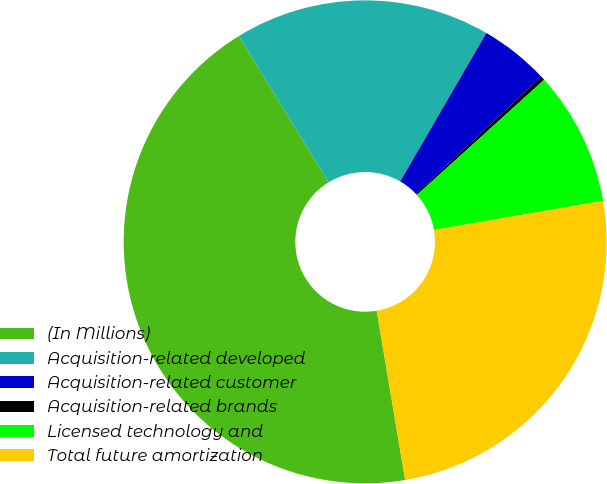Convert chart to OTSL. <chart><loc_0><loc_0><loc_500><loc_500><pie_chart><fcel>(In Millions)<fcel>Acquisition-related developed<fcel>Acquisition-related customer<fcel>Acquisition-related brands<fcel>Licensed technology and<fcel>Total future amortization<nl><fcel>43.89%<fcel>17.12%<fcel>4.64%<fcel>0.28%<fcel>9.0%<fcel>25.06%<nl></chart> 